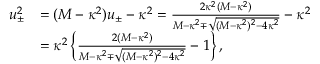<formula> <loc_0><loc_0><loc_500><loc_500>\begin{array} { r l } { u _ { \pm } ^ { 2 } } & { = ( M - \kappa ^ { 2 } ) u _ { \pm } - \kappa ^ { 2 } = \frac { 2 \kappa ^ { 2 } ( M - \kappa ^ { 2 } ) } { M - \kappa ^ { 2 } \mp \sqrt { ( M - \kappa ^ { 2 } ) ^ { 2 } - 4 \kappa ^ { 2 } } } - \kappa ^ { 2 } } \\ & { = \kappa ^ { 2 } \left \{ \frac { 2 ( M - \kappa ^ { 2 } ) } { M - \kappa ^ { 2 } \mp \sqrt { ( M - \kappa ^ { 2 } ) ^ { 2 } - 4 \kappa ^ { 2 } } } - 1 \right \} , } \end{array}</formula> 